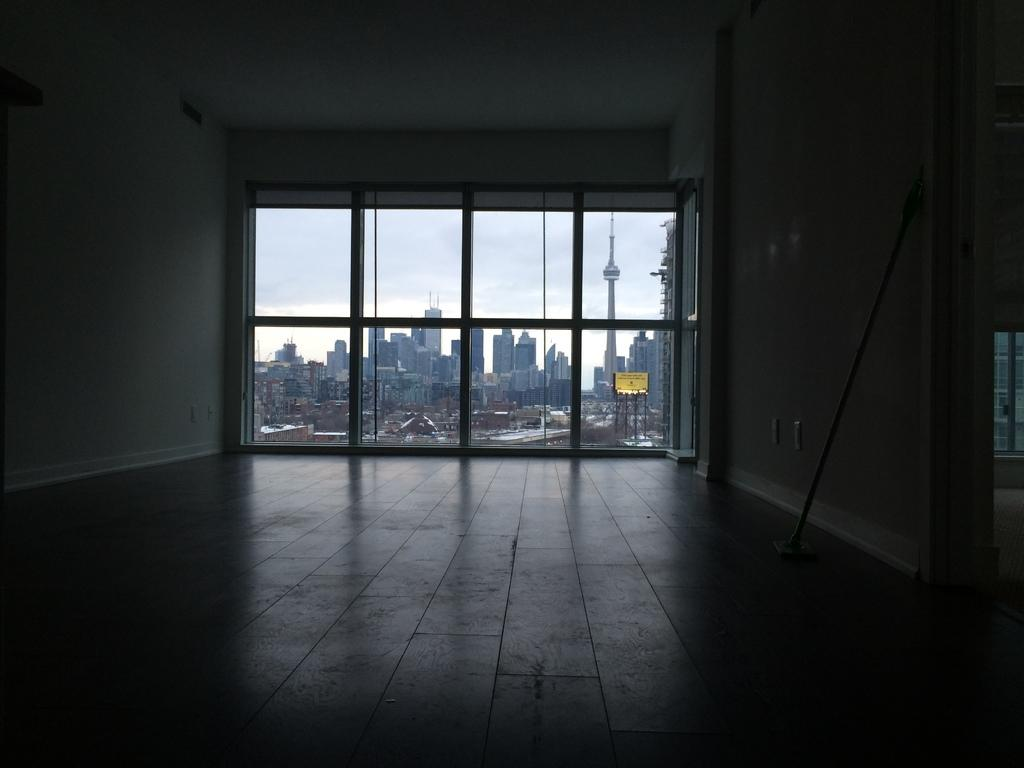What type of location is depicted in the image? The image is an inside view of a room. What feature allows natural light to enter the room? There is a window in the room in the room. What can be seen outside the window? Buildings are visible in the background. What structure is present in the background, separate from the buildings? There is a board on poles in the background. What type of soup is being served in the image? There is no soup present in the image; it is an inside view of a room with a window and a background view of buildings and a board on poles. 